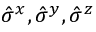Convert formula to latex. <formula><loc_0><loc_0><loc_500><loc_500>\hat { \sigma } ^ { x } , \hat { \sigma } ^ { y } , \hat { \sigma } ^ { z }</formula> 